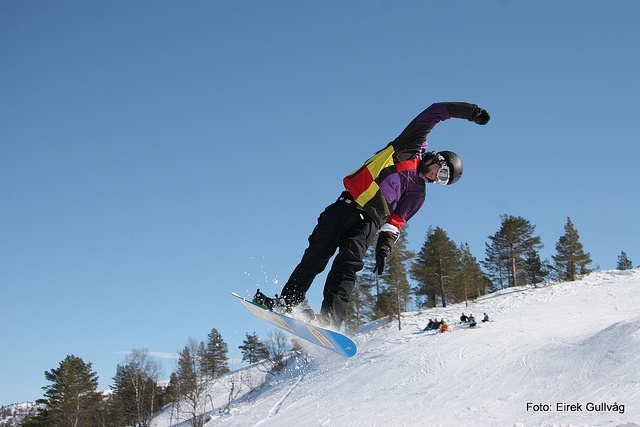Describe the objects in this image and their specific colors. I can see people in gray, black, darkgray, and olive tones, snowboard in gray and darkgray tones, people in gray, black, and darkgray tones, people in gray, black, navy, and lavender tones, and people in gray, darkgray, black, and lightgray tones in this image. 